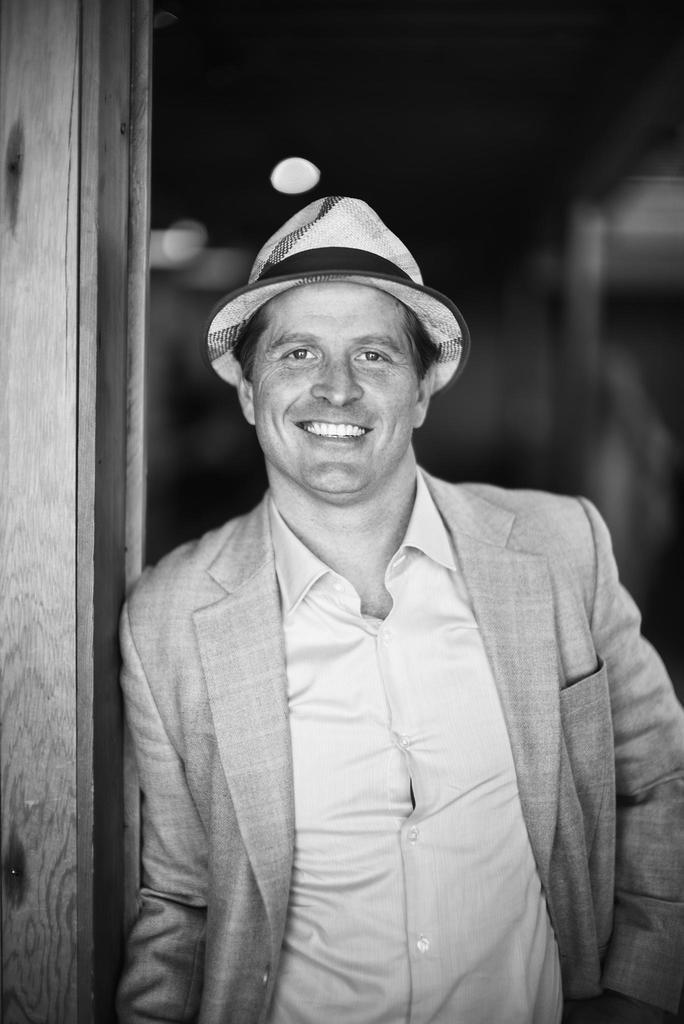How would you summarize this image in a sentence or two? It looks like a black and white picture. We can see a man with a hat is smiling and standing on the path and behind the man there is a dark background. 